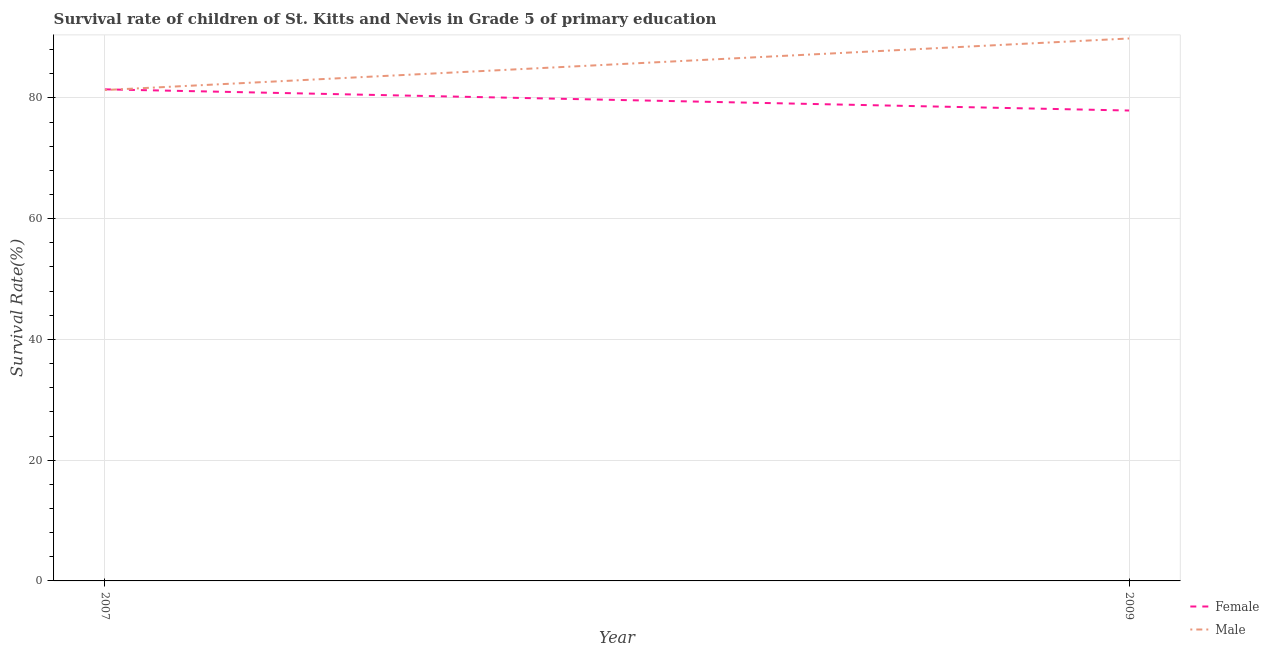Does the line corresponding to survival rate of male students in primary education intersect with the line corresponding to survival rate of female students in primary education?
Offer a terse response. Yes. Is the number of lines equal to the number of legend labels?
Give a very brief answer. Yes. What is the survival rate of male students in primary education in 2009?
Give a very brief answer. 89.83. Across all years, what is the maximum survival rate of male students in primary education?
Provide a succinct answer. 89.83. Across all years, what is the minimum survival rate of male students in primary education?
Give a very brief answer. 81.3. In which year was the survival rate of female students in primary education maximum?
Offer a terse response. 2007. In which year was the survival rate of female students in primary education minimum?
Offer a very short reply. 2009. What is the total survival rate of female students in primary education in the graph?
Ensure brevity in your answer.  159.31. What is the difference between the survival rate of female students in primary education in 2007 and that in 2009?
Keep it short and to the point. 3.51. What is the difference between the survival rate of male students in primary education in 2009 and the survival rate of female students in primary education in 2007?
Your answer should be compact. 8.43. What is the average survival rate of female students in primary education per year?
Offer a very short reply. 79.66. In the year 2007, what is the difference between the survival rate of female students in primary education and survival rate of male students in primary education?
Ensure brevity in your answer.  0.11. In how many years, is the survival rate of female students in primary education greater than 16 %?
Provide a succinct answer. 2. What is the ratio of the survival rate of female students in primary education in 2007 to that in 2009?
Offer a very short reply. 1.05. Is the survival rate of female students in primary education in 2007 less than that in 2009?
Your answer should be very brief. No. Does the survival rate of female students in primary education monotonically increase over the years?
Keep it short and to the point. No. Are the values on the major ticks of Y-axis written in scientific E-notation?
Your response must be concise. No. Does the graph contain any zero values?
Your answer should be very brief. No. Where does the legend appear in the graph?
Your response must be concise. Bottom right. What is the title of the graph?
Offer a terse response. Survival rate of children of St. Kitts and Nevis in Grade 5 of primary education. What is the label or title of the X-axis?
Give a very brief answer. Year. What is the label or title of the Y-axis?
Offer a terse response. Survival Rate(%). What is the Survival Rate(%) in Female in 2007?
Your answer should be very brief. 81.41. What is the Survival Rate(%) in Male in 2007?
Ensure brevity in your answer.  81.3. What is the Survival Rate(%) of Female in 2009?
Offer a very short reply. 77.9. What is the Survival Rate(%) in Male in 2009?
Ensure brevity in your answer.  89.83. Across all years, what is the maximum Survival Rate(%) in Female?
Ensure brevity in your answer.  81.41. Across all years, what is the maximum Survival Rate(%) in Male?
Ensure brevity in your answer.  89.83. Across all years, what is the minimum Survival Rate(%) in Female?
Make the answer very short. 77.9. Across all years, what is the minimum Survival Rate(%) of Male?
Keep it short and to the point. 81.3. What is the total Survival Rate(%) of Female in the graph?
Provide a succinct answer. 159.31. What is the total Survival Rate(%) in Male in the graph?
Make the answer very short. 171.13. What is the difference between the Survival Rate(%) in Female in 2007 and that in 2009?
Ensure brevity in your answer.  3.51. What is the difference between the Survival Rate(%) in Male in 2007 and that in 2009?
Provide a short and direct response. -8.54. What is the difference between the Survival Rate(%) in Female in 2007 and the Survival Rate(%) in Male in 2009?
Give a very brief answer. -8.43. What is the average Survival Rate(%) in Female per year?
Make the answer very short. 79.66. What is the average Survival Rate(%) of Male per year?
Offer a terse response. 85.57. In the year 2007, what is the difference between the Survival Rate(%) of Female and Survival Rate(%) of Male?
Give a very brief answer. 0.11. In the year 2009, what is the difference between the Survival Rate(%) of Female and Survival Rate(%) of Male?
Keep it short and to the point. -11.93. What is the ratio of the Survival Rate(%) in Female in 2007 to that in 2009?
Make the answer very short. 1.04. What is the ratio of the Survival Rate(%) of Male in 2007 to that in 2009?
Your answer should be compact. 0.9. What is the difference between the highest and the second highest Survival Rate(%) in Female?
Your answer should be very brief. 3.51. What is the difference between the highest and the second highest Survival Rate(%) of Male?
Your answer should be compact. 8.54. What is the difference between the highest and the lowest Survival Rate(%) in Female?
Provide a succinct answer. 3.51. What is the difference between the highest and the lowest Survival Rate(%) in Male?
Give a very brief answer. 8.54. 